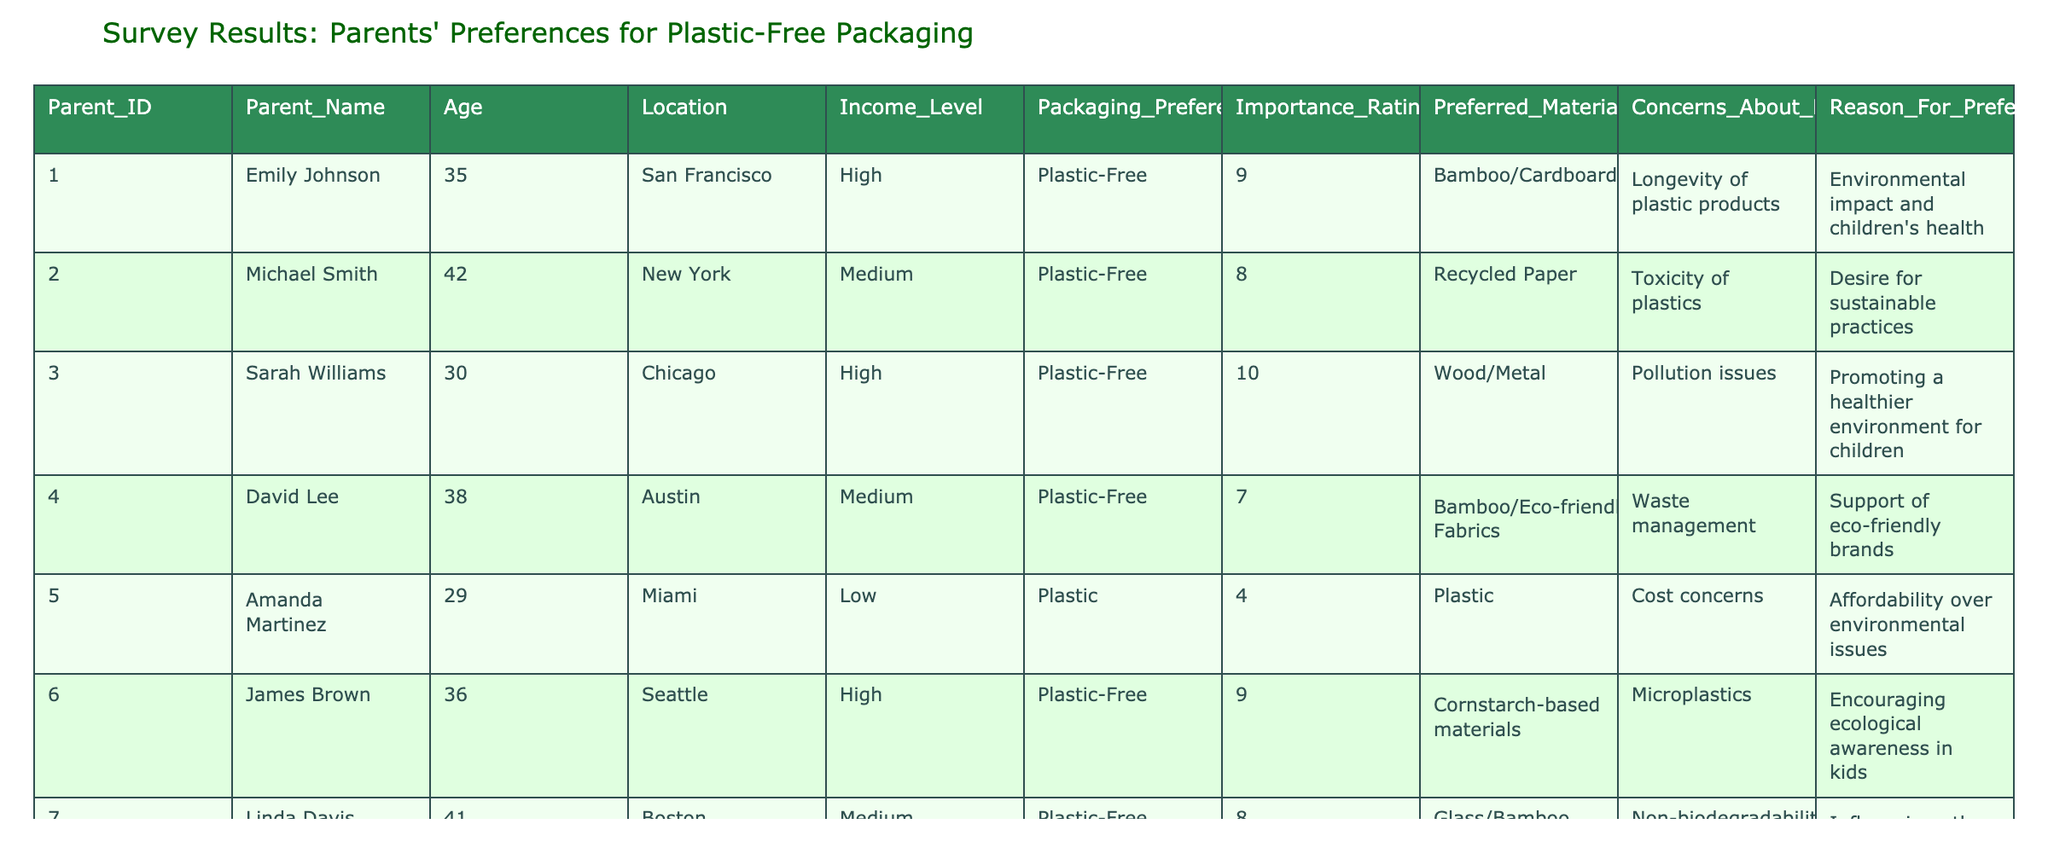What is the highest importance rating given by a parent? The highest importance rating in the table is 10, which was given by both Sarah Williams and Nancy Hernandez.
Answer: 10 What materials do parents prefer when opting for plastic-free packaging? The preferred materials for plastic-free packaging include Bamboo, Cardboard, Recycled Paper, Wood, Metal, Cornstarch-based materials, Glass, and Cotton.
Answer: Bamboo, Cardboard, Recycled Paper, Wood, Metal, Cornstarch-based materials, Glass, Cotton How many parents prefer plastic over plastic-free packaging? There are 3 parents who prefer plastic (Amanda Martinez, Robert Garcia, and William Wilson) out of 10 total parents.
Answer: 3 What is the average importance rating of parents who prefer plastic-free packaging? The importance ratings for parents preferring plastic-free packaging are 9, 8, 10, 7, 9, 8, 10, and 6. Adding these ratings gives 67, and dividing by the 8 parents results in an average of 8.375.
Answer: 8.375 Is there a parent from Miami who prefers plastic-free packaging? No, Amanda Martinez is from Miami and she prefers plastic packaging, not plastic-free packaging.
Answer: No Which location has the highest income level among parents preferring plastic-free packaging? The parent from San Francisco (Emily Johnson) has a high-income level and prefers plastic-free packaging, making it the highest among other locations present.
Answer: San Francisco What percentage of parents express concerns about pollution or environmental impact? Five out of ten parents express concerns related to pollution or environmental impact: Emily Johnson, Michael Smith, Sarah Williams, David Lee, and Nancy Hernandez. This translates to 50% of the surveyed parents.
Answer: 50% Which material is preferred by the lowest-rated plastic-free packaging parent? The parent with the lowest importance rating who prefers plastic-free packaging is William Wilson, who prefers Cotton and Eco-friendly plastics.
Answer: Cotton and Eco-friendly plastics How does the income level correlate with preferences for plastic-free packaging among parents in high-income areas? In high-income areas (San Francisco, Chicago, and Seattle), all parents prefer plastic-free packaging, contributing to a pattern suggesting a tendency for higher-income parents to favor sustainable options.
Answer: Positive correlation 